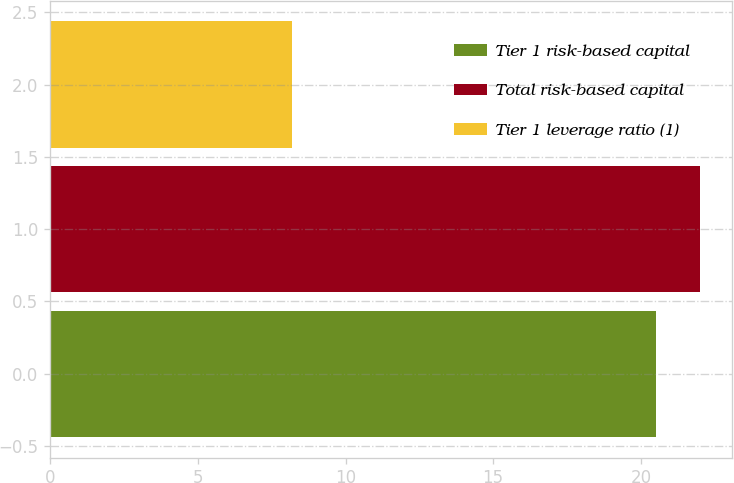<chart> <loc_0><loc_0><loc_500><loc_500><bar_chart><fcel>Tier 1 risk-based capital<fcel>Total risk-based capital<fcel>Tier 1 leverage ratio (1)<nl><fcel>20.5<fcel>22<fcel>8.2<nl></chart> 